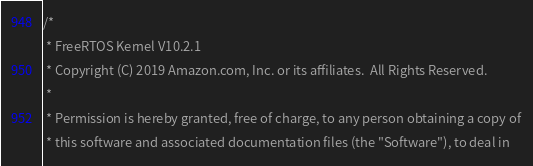Convert code to text. <code><loc_0><loc_0><loc_500><loc_500><_C_>/*
 * FreeRTOS Kernel V10.2.1
 * Copyright (C) 2019 Amazon.com, Inc. or its affiliates.  All Rights Reserved.
 *
 * Permission is hereby granted, free of charge, to any person obtaining a copy of
 * this software and associated documentation files (the "Software"), to deal in</code> 